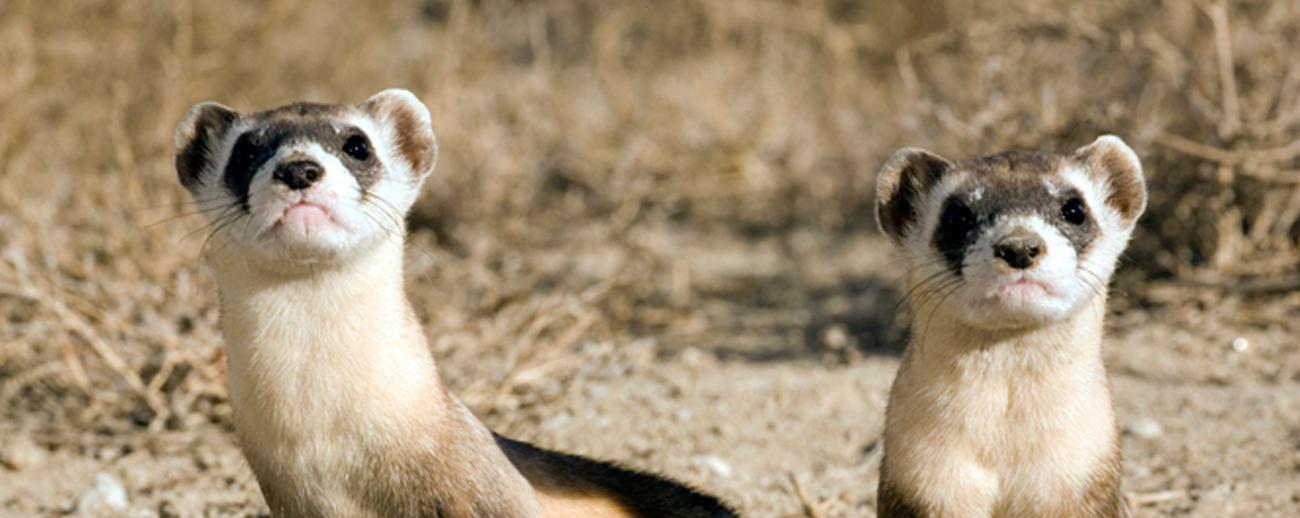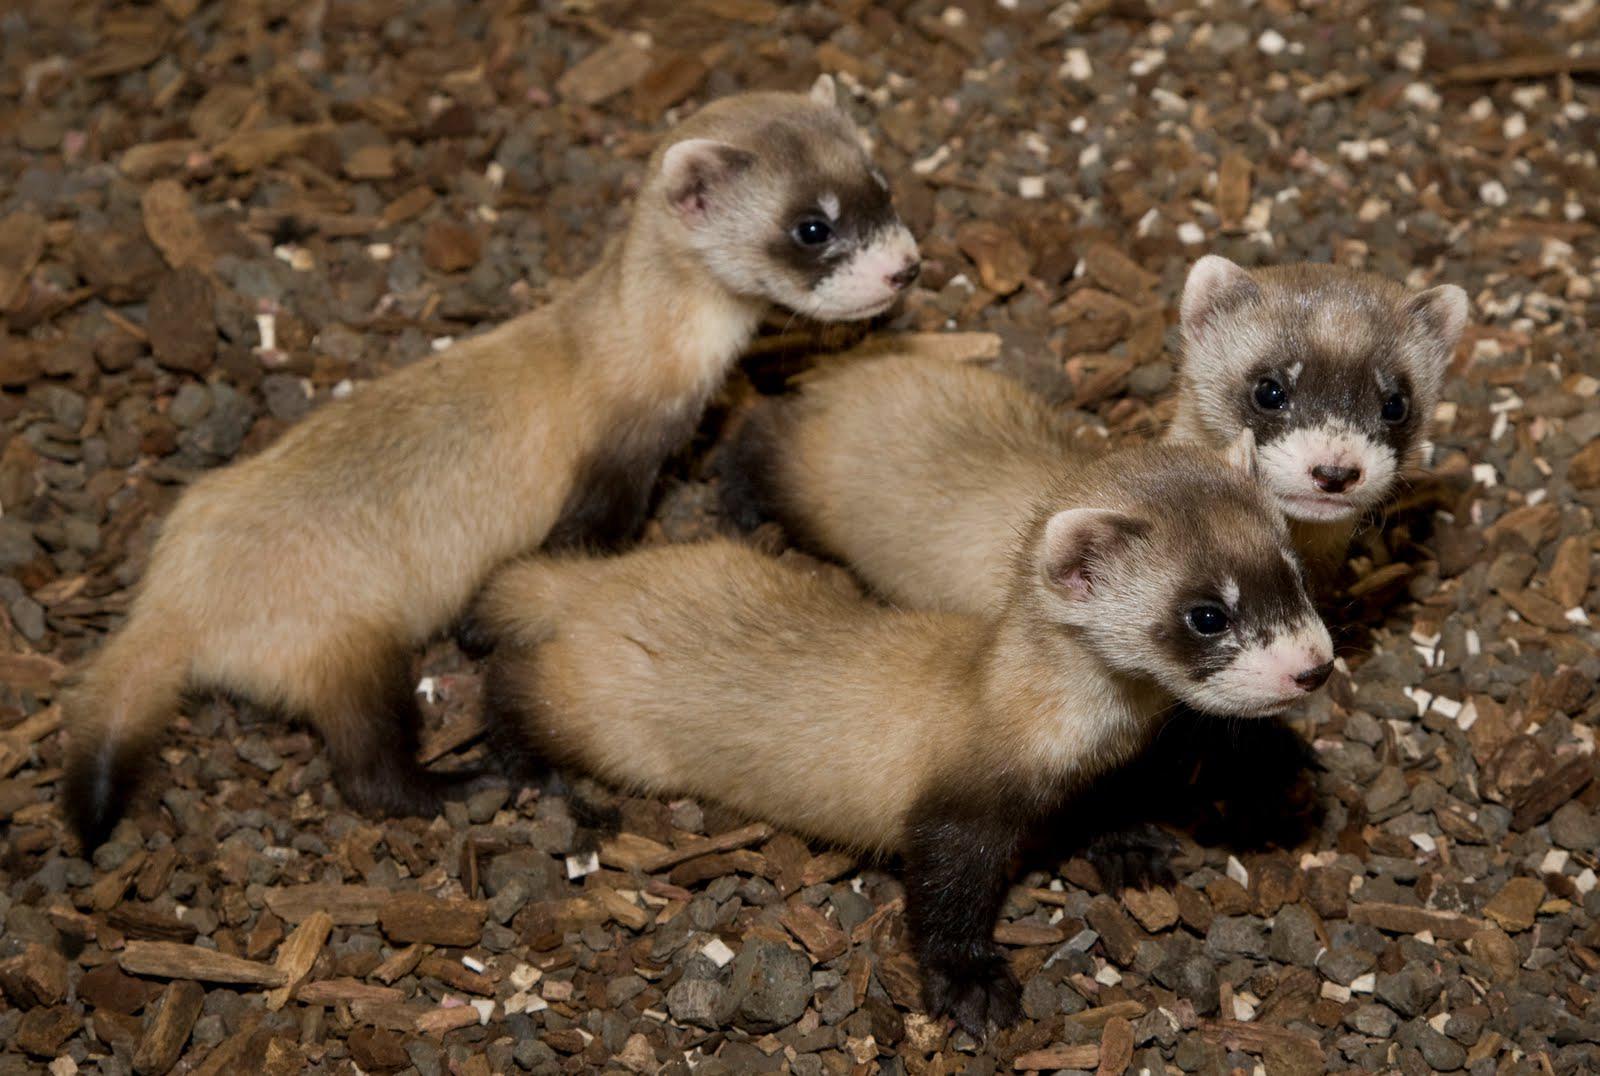The first image is the image on the left, the second image is the image on the right. Given the left and right images, does the statement "There are four ferrets" hold true? Answer yes or no. No. 